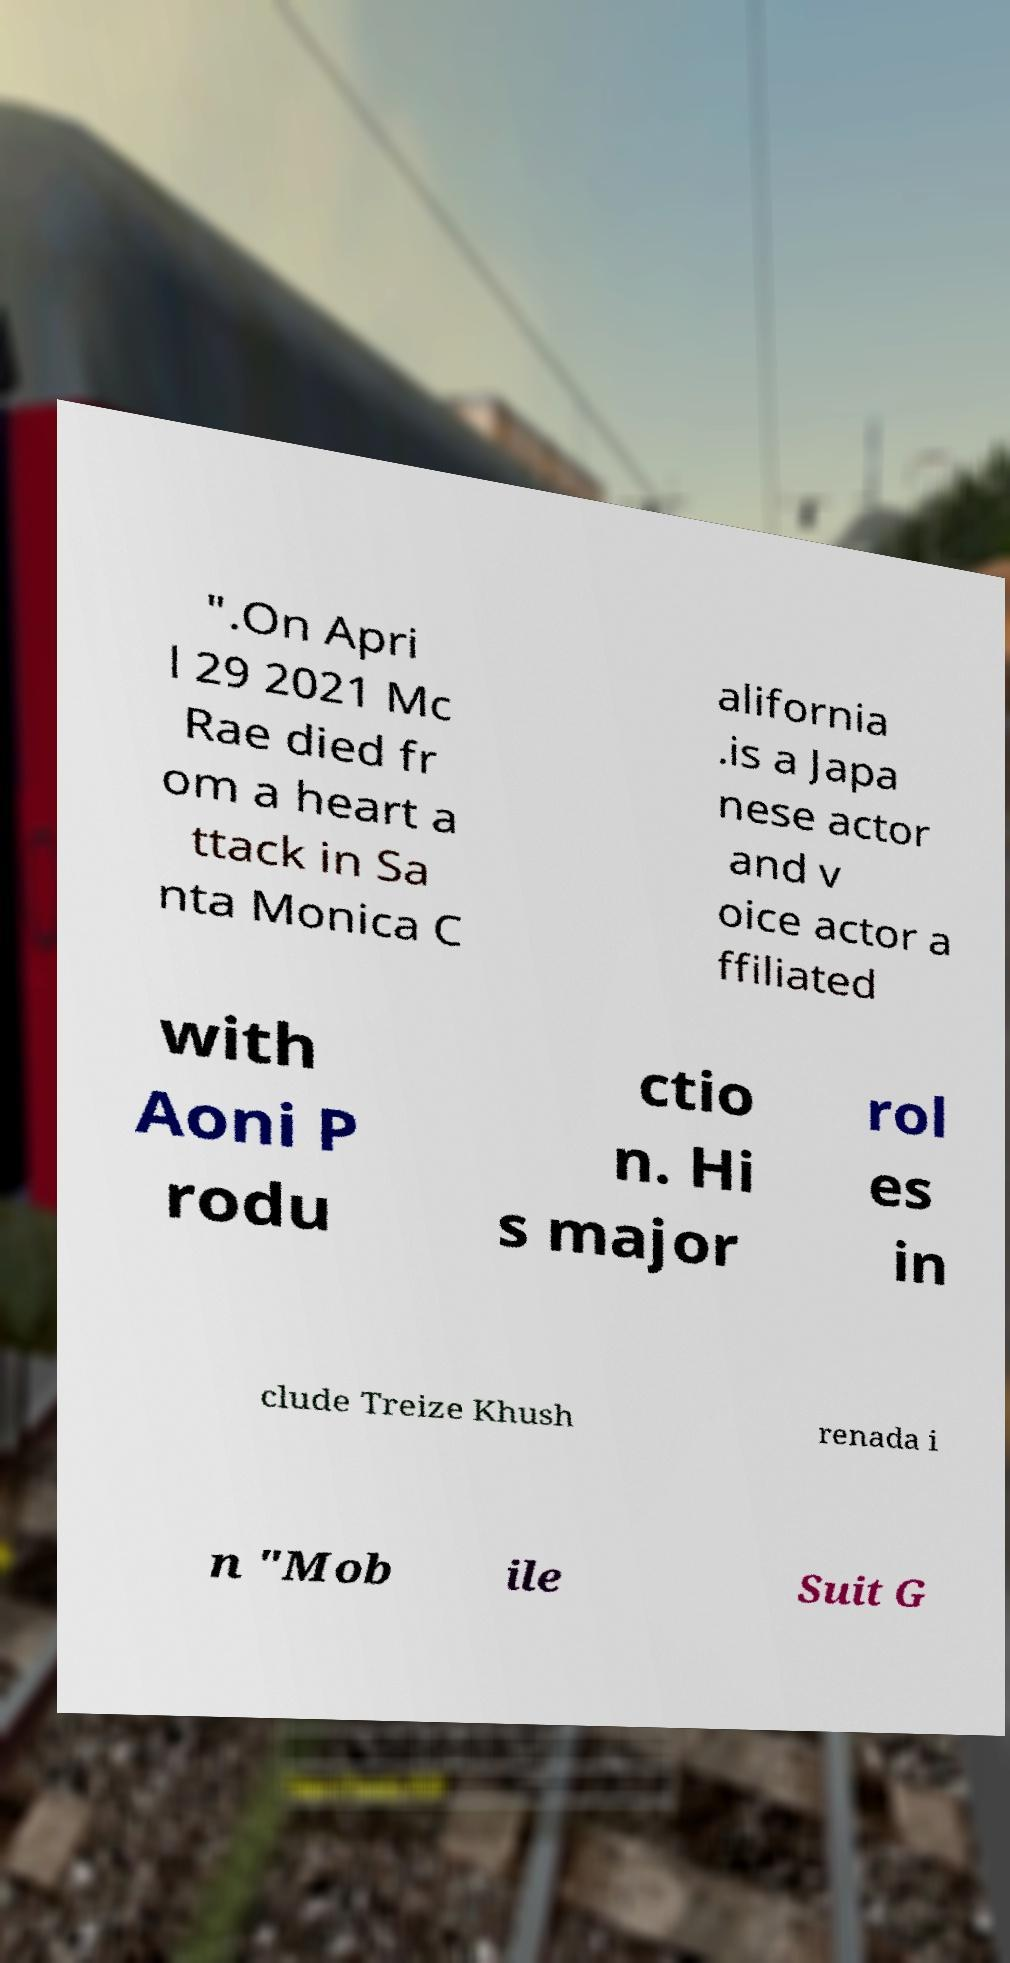I need the written content from this picture converted into text. Can you do that? ".On Apri l 29 2021 Mc Rae died fr om a heart a ttack in Sa nta Monica C alifornia .is a Japa nese actor and v oice actor a ffiliated with Aoni P rodu ctio n. Hi s major rol es in clude Treize Khush renada i n "Mob ile Suit G 